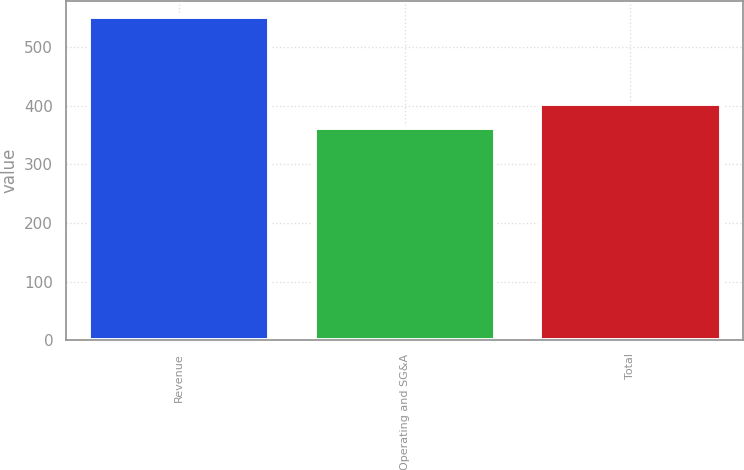<chart> <loc_0><loc_0><loc_500><loc_500><bar_chart><fcel>Revenue<fcel>Operating and SG&A<fcel>Total<nl><fcel>550.7<fcel>362.2<fcel>403.1<nl></chart> 